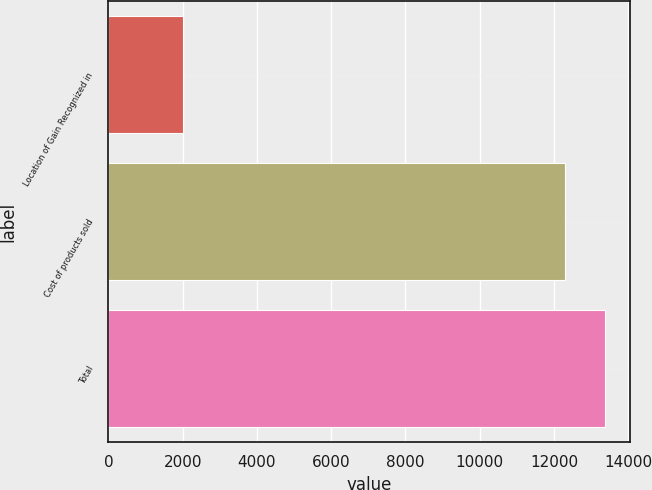Convert chart. <chart><loc_0><loc_0><loc_500><loc_500><bar_chart><fcel>Location of Gain Recognized in<fcel>Cost of products sold<fcel>Total<nl><fcel>2012<fcel>12295<fcel>13380.6<nl></chart> 